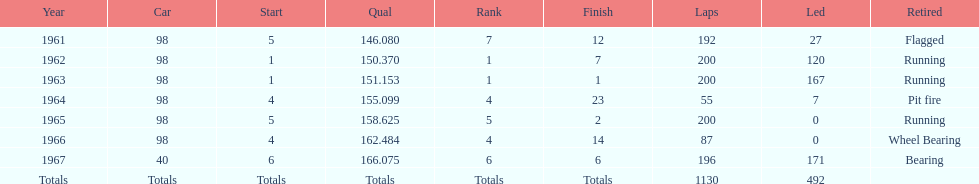In which year(s) did parnelli achieve a 4th place finish or higher? 1963, 1965. 